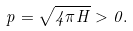<formula> <loc_0><loc_0><loc_500><loc_500>p = \sqrt { 4 \pi H } > 0 .</formula> 